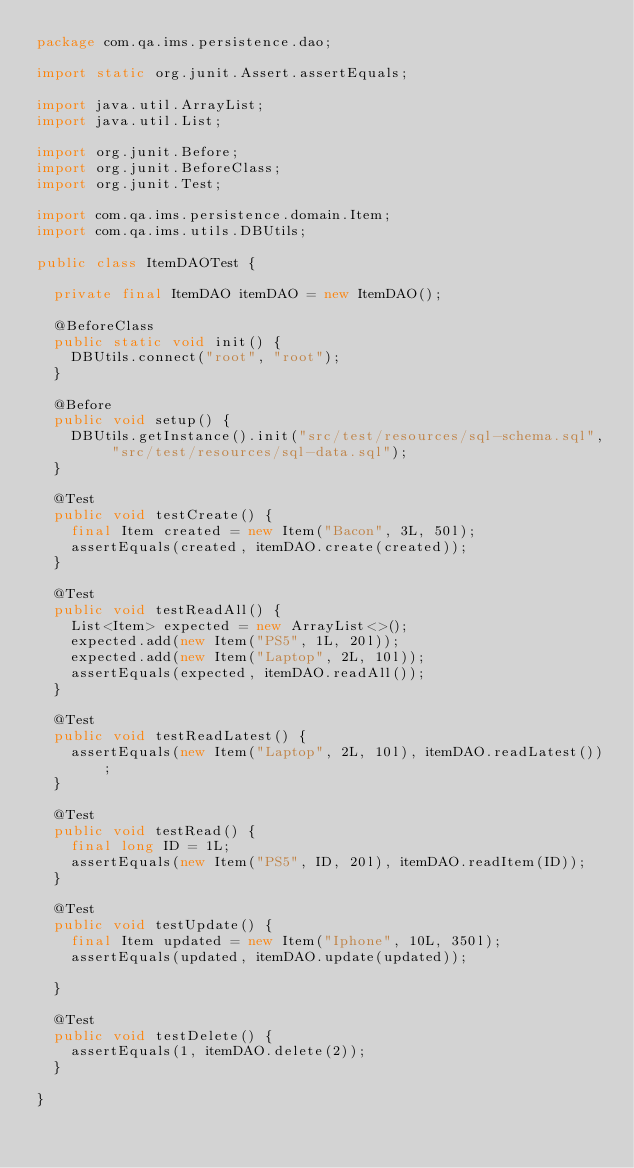<code> <loc_0><loc_0><loc_500><loc_500><_Java_>package com.qa.ims.persistence.dao;

import static org.junit.Assert.assertEquals;

import java.util.ArrayList;
import java.util.List;

import org.junit.Before;
import org.junit.BeforeClass;
import org.junit.Test;

import com.qa.ims.persistence.domain.Item;
import com.qa.ims.utils.DBUtils;

public class ItemDAOTest {

	private final ItemDAO itemDAO = new ItemDAO();

	@BeforeClass
	public static void init() {
		DBUtils.connect("root", "root");
	}

	@Before
	public void setup() {
		DBUtils.getInstance().init("src/test/resources/sql-schema.sql", "src/test/resources/sql-data.sql");
	}

	@Test
	public void testCreate() {
		final Item created = new Item("Bacon", 3L, 50l);
		assertEquals(created, itemDAO.create(created));
	}

	@Test
	public void testReadAll() {
		List<Item> expected = new ArrayList<>();
		expected.add(new Item("PS5", 1L, 20l));
		expected.add(new Item("Laptop", 2L, 10l));
		assertEquals(expected, itemDAO.readAll());
	}

	@Test
	public void testReadLatest() {
		assertEquals(new Item("Laptop", 2L, 10l), itemDAO.readLatest());
	}

	@Test
	public void testRead() {
		final long ID = 1L;
		assertEquals(new Item("PS5", ID, 20l), itemDAO.readItem(ID));
	}

	@Test
	public void testUpdate() {
		final Item updated = new Item("Iphone", 10L, 350l);
		assertEquals(updated, itemDAO.update(updated));

	}

	@Test
	public void testDelete() {
		assertEquals(1, itemDAO.delete(2));
	}
	
}</code> 